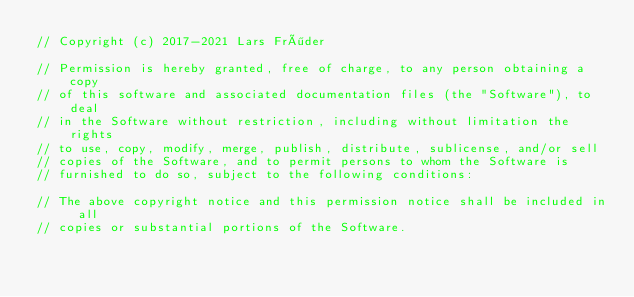<code> <loc_0><loc_0><loc_500><loc_500><_ObjectiveC_>// Copyright (c) 2017-2021 Lars Fröder

// Permission is hereby granted, free of charge, to any person obtaining a copy
// of this software and associated documentation files (the "Software"), to deal
// in the Software without restriction, including without limitation the rights
// to use, copy, modify, merge, publish, distribute, sublicense, and/or sell
// copies of the Software, and to permit persons to whom the Software is
// furnished to do so, subject to the following conditions:

// The above copyright notice and this permission notice shall be included in all
// copies or substantial portions of the Software.
</code> 